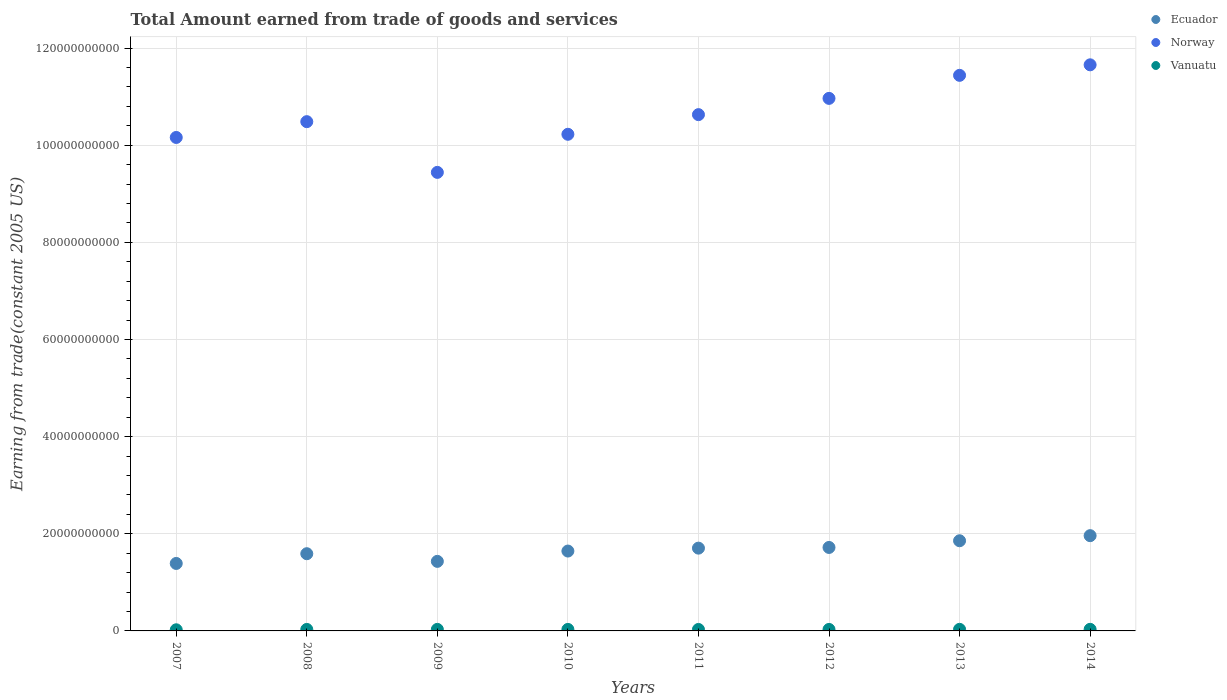How many different coloured dotlines are there?
Your answer should be very brief. 3. Is the number of dotlines equal to the number of legend labels?
Your response must be concise. Yes. What is the total amount earned by trading goods and services in Norway in 2014?
Your answer should be compact. 1.17e+11. Across all years, what is the maximum total amount earned by trading goods and services in Ecuador?
Your response must be concise. 1.96e+1. Across all years, what is the minimum total amount earned by trading goods and services in Norway?
Your response must be concise. 9.44e+1. What is the total total amount earned by trading goods and services in Vanuatu in the graph?
Keep it short and to the point. 2.42e+09. What is the difference between the total amount earned by trading goods and services in Ecuador in 2010 and that in 2014?
Give a very brief answer. -3.17e+09. What is the difference between the total amount earned by trading goods and services in Vanuatu in 2011 and the total amount earned by trading goods and services in Ecuador in 2013?
Offer a very short reply. -1.83e+1. What is the average total amount earned by trading goods and services in Norway per year?
Ensure brevity in your answer.  1.06e+11. In the year 2007, what is the difference between the total amount earned by trading goods and services in Vanuatu and total amount earned by trading goods and services in Norway?
Provide a short and direct response. -1.01e+11. What is the ratio of the total amount earned by trading goods and services in Norway in 2009 to that in 2011?
Offer a terse response. 0.89. Is the difference between the total amount earned by trading goods and services in Vanuatu in 2012 and 2014 greater than the difference between the total amount earned by trading goods and services in Norway in 2012 and 2014?
Offer a very short reply. Yes. What is the difference between the highest and the second highest total amount earned by trading goods and services in Ecuador?
Offer a very short reply. 1.05e+09. What is the difference between the highest and the lowest total amount earned by trading goods and services in Ecuador?
Give a very brief answer. 5.72e+09. In how many years, is the total amount earned by trading goods and services in Ecuador greater than the average total amount earned by trading goods and services in Ecuador taken over all years?
Keep it short and to the point. 4. Is it the case that in every year, the sum of the total amount earned by trading goods and services in Vanuatu and total amount earned by trading goods and services in Ecuador  is greater than the total amount earned by trading goods and services in Norway?
Offer a terse response. No. Are the values on the major ticks of Y-axis written in scientific E-notation?
Make the answer very short. No. Does the graph contain any zero values?
Provide a short and direct response. No. Does the graph contain grids?
Your answer should be compact. Yes. Where does the legend appear in the graph?
Your response must be concise. Top right. How are the legend labels stacked?
Give a very brief answer. Vertical. What is the title of the graph?
Give a very brief answer. Total Amount earned from trade of goods and services. What is the label or title of the X-axis?
Provide a short and direct response. Years. What is the label or title of the Y-axis?
Keep it short and to the point. Earning from trade(constant 2005 US). What is the Earning from trade(constant 2005 US) in Ecuador in 2007?
Your answer should be very brief. 1.39e+1. What is the Earning from trade(constant 2005 US) of Norway in 2007?
Your answer should be compact. 1.02e+11. What is the Earning from trade(constant 2005 US) of Vanuatu in 2007?
Provide a succinct answer. 2.33e+08. What is the Earning from trade(constant 2005 US) in Ecuador in 2008?
Provide a short and direct response. 1.59e+1. What is the Earning from trade(constant 2005 US) of Norway in 2008?
Ensure brevity in your answer.  1.05e+11. What is the Earning from trade(constant 2005 US) in Vanuatu in 2008?
Provide a succinct answer. 3.06e+08. What is the Earning from trade(constant 2005 US) of Ecuador in 2009?
Your response must be concise. 1.43e+1. What is the Earning from trade(constant 2005 US) in Norway in 2009?
Offer a terse response. 9.44e+1. What is the Earning from trade(constant 2005 US) of Vanuatu in 2009?
Ensure brevity in your answer.  3.15e+08. What is the Earning from trade(constant 2005 US) in Ecuador in 2010?
Make the answer very short. 1.64e+1. What is the Earning from trade(constant 2005 US) of Norway in 2010?
Your answer should be compact. 1.02e+11. What is the Earning from trade(constant 2005 US) of Vanuatu in 2010?
Provide a succinct answer. 3.09e+08. What is the Earning from trade(constant 2005 US) of Ecuador in 2011?
Provide a succinct answer. 1.70e+1. What is the Earning from trade(constant 2005 US) in Norway in 2011?
Ensure brevity in your answer.  1.06e+11. What is the Earning from trade(constant 2005 US) of Vanuatu in 2011?
Your answer should be compact. 3.03e+08. What is the Earning from trade(constant 2005 US) in Ecuador in 2012?
Make the answer very short. 1.72e+1. What is the Earning from trade(constant 2005 US) in Norway in 2012?
Give a very brief answer. 1.10e+11. What is the Earning from trade(constant 2005 US) of Vanuatu in 2012?
Keep it short and to the point. 3.05e+08. What is the Earning from trade(constant 2005 US) in Ecuador in 2013?
Keep it short and to the point. 1.86e+1. What is the Earning from trade(constant 2005 US) of Norway in 2013?
Give a very brief answer. 1.14e+11. What is the Earning from trade(constant 2005 US) of Vanuatu in 2013?
Provide a succinct answer. 3.25e+08. What is the Earning from trade(constant 2005 US) of Ecuador in 2014?
Provide a succinct answer. 1.96e+1. What is the Earning from trade(constant 2005 US) of Norway in 2014?
Your response must be concise. 1.17e+11. What is the Earning from trade(constant 2005 US) in Vanuatu in 2014?
Provide a short and direct response. 3.26e+08. Across all years, what is the maximum Earning from trade(constant 2005 US) of Ecuador?
Your answer should be very brief. 1.96e+1. Across all years, what is the maximum Earning from trade(constant 2005 US) in Norway?
Provide a short and direct response. 1.17e+11. Across all years, what is the maximum Earning from trade(constant 2005 US) in Vanuatu?
Give a very brief answer. 3.26e+08. Across all years, what is the minimum Earning from trade(constant 2005 US) in Ecuador?
Provide a succinct answer. 1.39e+1. Across all years, what is the minimum Earning from trade(constant 2005 US) in Norway?
Give a very brief answer. 9.44e+1. Across all years, what is the minimum Earning from trade(constant 2005 US) of Vanuatu?
Your response must be concise. 2.33e+08. What is the total Earning from trade(constant 2005 US) of Ecuador in the graph?
Provide a succinct answer. 1.33e+11. What is the total Earning from trade(constant 2005 US) of Norway in the graph?
Your response must be concise. 8.50e+11. What is the total Earning from trade(constant 2005 US) in Vanuatu in the graph?
Make the answer very short. 2.42e+09. What is the difference between the Earning from trade(constant 2005 US) in Ecuador in 2007 and that in 2008?
Provide a succinct answer. -2.01e+09. What is the difference between the Earning from trade(constant 2005 US) in Norway in 2007 and that in 2008?
Your response must be concise. -3.25e+09. What is the difference between the Earning from trade(constant 2005 US) in Vanuatu in 2007 and that in 2008?
Give a very brief answer. -7.33e+07. What is the difference between the Earning from trade(constant 2005 US) of Ecuador in 2007 and that in 2009?
Offer a terse response. -4.29e+08. What is the difference between the Earning from trade(constant 2005 US) of Norway in 2007 and that in 2009?
Your answer should be very brief. 7.19e+09. What is the difference between the Earning from trade(constant 2005 US) in Vanuatu in 2007 and that in 2009?
Provide a short and direct response. -8.23e+07. What is the difference between the Earning from trade(constant 2005 US) in Ecuador in 2007 and that in 2010?
Ensure brevity in your answer.  -2.55e+09. What is the difference between the Earning from trade(constant 2005 US) in Norway in 2007 and that in 2010?
Your answer should be compact. -6.52e+08. What is the difference between the Earning from trade(constant 2005 US) in Vanuatu in 2007 and that in 2010?
Provide a succinct answer. -7.55e+07. What is the difference between the Earning from trade(constant 2005 US) of Ecuador in 2007 and that in 2011?
Offer a terse response. -3.15e+09. What is the difference between the Earning from trade(constant 2005 US) in Norway in 2007 and that in 2011?
Ensure brevity in your answer.  -4.70e+09. What is the difference between the Earning from trade(constant 2005 US) of Vanuatu in 2007 and that in 2011?
Offer a terse response. -6.95e+07. What is the difference between the Earning from trade(constant 2005 US) in Ecuador in 2007 and that in 2012?
Ensure brevity in your answer.  -3.29e+09. What is the difference between the Earning from trade(constant 2005 US) of Norway in 2007 and that in 2012?
Ensure brevity in your answer.  -8.05e+09. What is the difference between the Earning from trade(constant 2005 US) of Vanuatu in 2007 and that in 2012?
Your answer should be very brief. -7.21e+07. What is the difference between the Earning from trade(constant 2005 US) of Ecuador in 2007 and that in 2013?
Offer a terse response. -4.67e+09. What is the difference between the Earning from trade(constant 2005 US) in Norway in 2007 and that in 2013?
Offer a very short reply. -1.28e+1. What is the difference between the Earning from trade(constant 2005 US) in Vanuatu in 2007 and that in 2013?
Provide a succinct answer. -9.18e+07. What is the difference between the Earning from trade(constant 2005 US) in Ecuador in 2007 and that in 2014?
Ensure brevity in your answer.  -5.72e+09. What is the difference between the Earning from trade(constant 2005 US) in Norway in 2007 and that in 2014?
Give a very brief answer. -1.50e+1. What is the difference between the Earning from trade(constant 2005 US) in Vanuatu in 2007 and that in 2014?
Provide a succinct answer. -9.24e+07. What is the difference between the Earning from trade(constant 2005 US) in Ecuador in 2008 and that in 2009?
Keep it short and to the point. 1.58e+09. What is the difference between the Earning from trade(constant 2005 US) of Norway in 2008 and that in 2009?
Offer a terse response. 1.04e+1. What is the difference between the Earning from trade(constant 2005 US) in Vanuatu in 2008 and that in 2009?
Your answer should be compact. -9.04e+06. What is the difference between the Earning from trade(constant 2005 US) of Ecuador in 2008 and that in 2010?
Your answer should be compact. -5.46e+08. What is the difference between the Earning from trade(constant 2005 US) of Norway in 2008 and that in 2010?
Your answer should be compact. 2.60e+09. What is the difference between the Earning from trade(constant 2005 US) of Vanuatu in 2008 and that in 2010?
Your answer should be compact. -2.21e+06. What is the difference between the Earning from trade(constant 2005 US) in Ecuador in 2008 and that in 2011?
Keep it short and to the point. -1.15e+09. What is the difference between the Earning from trade(constant 2005 US) of Norway in 2008 and that in 2011?
Offer a terse response. -1.45e+09. What is the difference between the Earning from trade(constant 2005 US) of Vanuatu in 2008 and that in 2011?
Your answer should be compact. 3.74e+06. What is the difference between the Earning from trade(constant 2005 US) of Ecuador in 2008 and that in 2012?
Keep it short and to the point. -1.29e+09. What is the difference between the Earning from trade(constant 2005 US) of Norway in 2008 and that in 2012?
Offer a very short reply. -4.79e+09. What is the difference between the Earning from trade(constant 2005 US) in Vanuatu in 2008 and that in 2012?
Ensure brevity in your answer.  1.22e+06. What is the difference between the Earning from trade(constant 2005 US) of Ecuador in 2008 and that in 2013?
Ensure brevity in your answer.  -2.67e+09. What is the difference between the Earning from trade(constant 2005 US) of Norway in 2008 and that in 2013?
Offer a very short reply. -9.54e+09. What is the difference between the Earning from trade(constant 2005 US) in Vanuatu in 2008 and that in 2013?
Offer a very short reply. -1.85e+07. What is the difference between the Earning from trade(constant 2005 US) of Ecuador in 2008 and that in 2014?
Provide a short and direct response. -3.72e+09. What is the difference between the Earning from trade(constant 2005 US) in Norway in 2008 and that in 2014?
Offer a very short reply. -1.17e+1. What is the difference between the Earning from trade(constant 2005 US) in Vanuatu in 2008 and that in 2014?
Your response must be concise. -1.91e+07. What is the difference between the Earning from trade(constant 2005 US) of Ecuador in 2009 and that in 2010?
Offer a terse response. -2.12e+09. What is the difference between the Earning from trade(constant 2005 US) of Norway in 2009 and that in 2010?
Ensure brevity in your answer.  -7.84e+09. What is the difference between the Earning from trade(constant 2005 US) of Vanuatu in 2009 and that in 2010?
Provide a short and direct response. 6.83e+06. What is the difference between the Earning from trade(constant 2005 US) of Ecuador in 2009 and that in 2011?
Keep it short and to the point. -2.72e+09. What is the difference between the Earning from trade(constant 2005 US) of Norway in 2009 and that in 2011?
Provide a succinct answer. -1.19e+1. What is the difference between the Earning from trade(constant 2005 US) in Vanuatu in 2009 and that in 2011?
Ensure brevity in your answer.  1.28e+07. What is the difference between the Earning from trade(constant 2005 US) in Ecuador in 2009 and that in 2012?
Provide a short and direct response. -2.87e+09. What is the difference between the Earning from trade(constant 2005 US) of Norway in 2009 and that in 2012?
Offer a very short reply. -1.52e+1. What is the difference between the Earning from trade(constant 2005 US) in Vanuatu in 2009 and that in 2012?
Offer a terse response. 1.03e+07. What is the difference between the Earning from trade(constant 2005 US) in Ecuador in 2009 and that in 2013?
Your answer should be compact. -4.24e+09. What is the difference between the Earning from trade(constant 2005 US) of Norway in 2009 and that in 2013?
Provide a short and direct response. -2.00e+1. What is the difference between the Earning from trade(constant 2005 US) in Vanuatu in 2009 and that in 2013?
Your answer should be compact. -9.44e+06. What is the difference between the Earning from trade(constant 2005 US) in Ecuador in 2009 and that in 2014?
Your answer should be very brief. -5.29e+09. What is the difference between the Earning from trade(constant 2005 US) of Norway in 2009 and that in 2014?
Keep it short and to the point. -2.21e+1. What is the difference between the Earning from trade(constant 2005 US) in Vanuatu in 2009 and that in 2014?
Your answer should be compact. -1.01e+07. What is the difference between the Earning from trade(constant 2005 US) of Ecuador in 2010 and that in 2011?
Provide a succinct answer. -6.00e+08. What is the difference between the Earning from trade(constant 2005 US) of Norway in 2010 and that in 2011?
Keep it short and to the point. -4.05e+09. What is the difference between the Earning from trade(constant 2005 US) of Vanuatu in 2010 and that in 2011?
Offer a terse response. 5.95e+06. What is the difference between the Earning from trade(constant 2005 US) in Ecuador in 2010 and that in 2012?
Provide a short and direct response. -7.42e+08. What is the difference between the Earning from trade(constant 2005 US) of Norway in 2010 and that in 2012?
Your answer should be very brief. -7.39e+09. What is the difference between the Earning from trade(constant 2005 US) of Vanuatu in 2010 and that in 2012?
Make the answer very short. 3.43e+06. What is the difference between the Earning from trade(constant 2005 US) in Ecuador in 2010 and that in 2013?
Offer a very short reply. -2.12e+09. What is the difference between the Earning from trade(constant 2005 US) in Norway in 2010 and that in 2013?
Offer a terse response. -1.21e+1. What is the difference between the Earning from trade(constant 2005 US) in Vanuatu in 2010 and that in 2013?
Give a very brief answer. -1.63e+07. What is the difference between the Earning from trade(constant 2005 US) in Ecuador in 2010 and that in 2014?
Provide a short and direct response. -3.17e+09. What is the difference between the Earning from trade(constant 2005 US) of Norway in 2010 and that in 2014?
Your response must be concise. -1.43e+1. What is the difference between the Earning from trade(constant 2005 US) of Vanuatu in 2010 and that in 2014?
Your response must be concise. -1.69e+07. What is the difference between the Earning from trade(constant 2005 US) in Ecuador in 2011 and that in 2012?
Your answer should be compact. -1.42e+08. What is the difference between the Earning from trade(constant 2005 US) in Norway in 2011 and that in 2012?
Provide a short and direct response. -3.35e+09. What is the difference between the Earning from trade(constant 2005 US) of Vanuatu in 2011 and that in 2012?
Give a very brief answer. -2.51e+06. What is the difference between the Earning from trade(constant 2005 US) of Ecuador in 2011 and that in 2013?
Give a very brief answer. -1.52e+09. What is the difference between the Earning from trade(constant 2005 US) of Norway in 2011 and that in 2013?
Provide a short and direct response. -8.09e+09. What is the difference between the Earning from trade(constant 2005 US) in Vanuatu in 2011 and that in 2013?
Offer a very short reply. -2.22e+07. What is the difference between the Earning from trade(constant 2005 US) of Ecuador in 2011 and that in 2014?
Offer a terse response. -2.57e+09. What is the difference between the Earning from trade(constant 2005 US) of Norway in 2011 and that in 2014?
Your response must be concise. -1.03e+1. What is the difference between the Earning from trade(constant 2005 US) of Vanuatu in 2011 and that in 2014?
Your answer should be very brief. -2.29e+07. What is the difference between the Earning from trade(constant 2005 US) in Ecuador in 2012 and that in 2013?
Provide a short and direct response. -1.38e+09. What is the difference between the Earning from trade(constant 2005 US) in Norway in 2012 and that in 2013?
Make the answer very short. -4.74e+09. What is the difference between the Earning from trade(constant 2005 US) in Vanuatu in 2012 and that in 2013?
Your answer should be very brief. -1.97e+07. What is the difference between the Earning from trade(constant 2005 US) of Ecuador in 2012 and that in 2014?
Make the answer very short. -2.43e+09. What is the difference between the Earning from trade(constant 2005 US) of Norway in 2012 and that in 2014?
Your answer should be very brief. -6.91e+09. What is the difference between the Earning from trade(constant 2005 US) of Vanuatu in 2012 and that in 2014?
Your answer should be very brief. -2.04e+07. What is the difference between the Earning from trade(constant 2005 US) in Ecuador in 2013 and that in 2014?
Provide a short and direct response. -1.05e+09. What is the difference between the Earning from trade(constant 2005 US) of Norway in 2013 and that in 2014?
Make the answer very short. -2.17e+09. What is the difference between the Earning from trade(constant 2005 US) in Vanuatu in 2013 and that in 2014?
Provide a short and direct response. -6.49e+05. What is the difference between the Earning from trade(constant 2005 US) in Ecuador in 2007 and the Earning from trade(constant 2005 US) in Norway in 2008?
Make the answer very short. -9.10e+1. What is the difference between the Earning from trade(constant 2005 US) of Ecuador in 2007 and the Earning from trade(constant 2005 US) of Vanuatu in 2008?
Keep it short and to the point. 1.36e+1. What is the difference between the Earning from trade(constant 2005 US) of Norway in 2007 and the Earning from trade(constant 2005 US) of Vanuatu in 2008?
Ensure brevity in your answer.  1.01e+11. What is the difference between the Earning from trade(constant 2005 US) in Ecuador in 2007 and the Earning from trade(constant 2005 US) in Norway in 2009?
Keep it short and to the point. -8.05e+1. What is the difference between the Earning from trade(constant 2005 US) of Ecuador in 2007 and the Earning from trade(constant 2005 US) of Vanuatu in 2009?
Offer a very short reply. 1.36e+1. What is the difference between the Earning from trade(constant 2005 US) of Norway in 2007 and the Earning from trade(constant 2005 US) of Vanuatu in 2009?
Keep it short and to the point. 1.01e+11. What is the difference between the Earning from trade(constant 2005 US) in Ecuador in 2007 and the Earning from trade(constant 2005 US) in Norway in 2010?
Provide a succinct answer. -8.84e+1. What is the difference between the Earning from trade(constant 2005 US) in Ecuador in 2007 and the Earning from trade(constant 2005 US) in Vanuatu in 2010?
Give a very brief answer. 1.36e+1. What is the difference between the Earning from trade(constant 2005 US) of Norway in 2007 and the Earning from trade(constant 2005 US) of Vanuatu in 2010?
Offer a terse response. 1.01e+11. What is the difference between the Earning from trade(constant 2005 US) in Ecuador in 2007 and the Earning from trade(constant 2005 US) in Norway in 2011?
Offer a terse response. -9.24e+1. What is the difference between the Earning from trade(constant 2005 US) of Ecuador in 2007 and the Earning from trade(constant 2005 US) of Vanuatu in 2011?
Give a very brief answer. 1.36e+1. What is the difference between the Earning from trade(constant 2005 US) in Norway in 2007 and the Earning from trade(constant 2005 US) in Vanuatu in 2011?
Your response must be concise. 1.01e+11. What is the difference between the Earning from trade(constant 2005 US) in Ecuador in 2007 and the Earning from trade(constant 2005 US) in Norway in 2012?
Your answer should be very brief. -9.58e+1. What is the difference between the Earning from trade(constant 2005 US) of Ecuador in 2007 and the Earning from trade(constant 2005 US) of Vanuatu in 2012?
Your answer should be very brief. 1.36e+1. What is the difference between the Earning from trade(constant 2005 US) of Norway in 2007 and the Earning from trade(constant 2005 US) of Vanuatu in 2012?
Make the answer very short. 1.01e+11. What is the difference between the Earning from trade(constant 2005 US) in Ecuador in 2007 and the Earning from trade(constant 2005 US) in Norway in 2013?
Provide a succinct answer. -1.01e+11. What is the difference between the Earning from trade(constant 2005 US) in Ecuador in 2007 and the Earning from trade(constant 2005 US) in Vanuatu in 2013?
Keep it short and to the point. 1.36e+1. What is the difference between the Earning from trade(constant 2005 US) of Norway in 2007 and the Earning from trade(constant 2005 US) of Vanuatu in 2013?
Your answer should be compact. 1.01e+11. What is the difference between the Earning from trade(constant 2005 US) of Ecuador in 2007 and the Earning from trade(constant 2005 US) of Norway in 2014?
Ensure brevity in your answer.  -1.03e+11. What is the difference between the Earning from trade(constant 2005 US) of Ecuador in 2007 and the Earning from trade(constant 2005 US) of Vanuatu in 2014?
Keep it short and to the point. 1.36e+1. What is the difference between the Earning from trade(constant 2005 US) of Norway in 2007 and the Earning from trade(constant 2005 US) of Vanuatu in 2014?
Your response must be concise. 1.01e+11. What is the difference between the Earning from trade(constant 2005 US) in Ecuador in 2008 and the Earning from trade(constant 2005 US) in Norway in 2009?
Offer a terse response. -7.85e+1. What is the difference between the Earning from trade(constant 2005 US) in Ecuador in 2008 and the Earning from trade(constant 2005 US) in Vanuatu in 2009?
Give a very brief answer. 1.56e+1. What is the difference between the Earning from trade(constant 2005 US) in Norway in 2008 and the Earning from trade(constant 2005 US) in Vanuatu in 2009?
Your answer should be compact. 1.05e+11. What is the difference between the Earning from trade(constant 2005 US) in Ecuador in 2008 and the Earning from trade(constant 2005 US) in Norway in 2010?
Your answer should be very brief. -8.64e+1. What is the difference between the Earning from trade(constant 2005 US) of Ecuador in 2008 and the Earning from trade(constant 2005 US) of Vanuatu in 2010?
Make the answer very short. 1.56e+1. What is the difference between the Earning from trade(constant 2005 US) in Norway in 2008 and the Earning from trade(constant 2005 US) in Vanuatu in 2010?
Your answer should be very brief. 1.05e+11. What is the difference between the Earning from trade(constant 2005 US) of Ecuador in 2008 and the Earning from trade(constant 2005 US) of Norway in 2011?
Keep it short and to the point. -9.04e+1. What is the difference between the Earning from trade(constant 2005 US) in Ecuador in 2008 and the Earning from trade(constant 2005 US) in Vanuatu in 2011?
Your answer should be very brief. 1.56e+1. What is the difference between the Earning from trade(constant 2005 US) of Norway in 2008 and the Earning from trade(constant 2005 US) of Vanuatu in 2011?
Your answer should be very brief. 1.05e+11. What is the difference between the Earning from trade(constant 2005 US) in Ecuador in 2008 and the Earning from trade(constant 2005 US) in Norway in 2012?
Make the answer very short. -9.38e+1. What is the difference between the Earning from trade(constant 2005 US) in Ecuador in 2008 and the Earning from trade(constant 2005 US) in Vanuatu in 2012?
Offer a very short reply. 1.56e+1. What is the difference between the Earning from trade(constant 2005 US) of Norway in 2008 and the Earning from trade(constant 2005 US) of Vanuatu in 2012?
Provide a short and direct response. 1.05e+11. What is the difference between the Earning from trade(constant 2005 US) of Ecuador in 2008 and the Earning from trade(constant 2005 US) of Norway in 2013?
Make the answer very short. -9.85e+1. What is the difference between the Earning from trade(constant 2005 US) in Ecuador in 2008 and the Earning from trade(constant 2005 US) in Vanuatu in 2013?
Your answer should be compact. 1.56e+1. What is the difference between the Earning from trade(constant 2005 US) of Norway in 2008 and the Earning from trade(constant 2005 US) of Vanuatu in 2013?
Your answer should be compact. 1.05e+11. What is the difference between the Earning from trade(constant 2005 US) of Ecuador in 2008 and the Earning from trade(constant 2005 US) of Norway in 2014?
Your answer should be compact. -1.01e+11. What is the difference between the Earning from trade(constant 2005 US) of Ecuador in 2008 and the Earning from trade(constant 2005 US) of Vanuatu in 2014?
Keep it short and to the point. 1.56e+1. What is the difference between the Earning from trade(constant 2005 US) of Norway in 2008 and the Earning from trade(constant 2005 US) of Vanuatu in 2014?
Provide a short and direct response. 1.05e+11. What is the difference between the Earning from trade(constant 2005 US) in Ecuador in 2009 and the Earning from trade(constant 2005 US) in Norway in 2010?
Ensure brevity in your answer.  -8.79e+1. What is the difference between the Earning from trade(constant 2005 US) in Ecuador in 2009 and the Earning from trade(constant 2005 US) in Vanuatu in 2010?
Offer a very short reply. 1.40e+1. What is the difference between the Earning from trade(constant 2005 US) in Norway in 2009 and the Earning from trade(constant 2005 US) in Vanuatu in 2010?
Your response must be concise. 9.41e+1. What is the difference between the Earning from trade(constant 2005 US) in Ecuador in 2009 and the Earning from trade(constant 2005 US) in Norway in 2011?
Your answer should be very brief. -9.20e+1. What is the difference between the Earning from trade(constant 2005 US) of Ecuador in 2009 and the Earning from trade(constant 2005 US) of Vanuatu in 2011?
Give a very brief answer. 1.40e+1. What is the difference between the Earning from trade(constant 2005 US) in Norway in 2009 and the Earning from trade(constant 2005 US) in Vanuatu in 2011?
Keep it short and to the point. 9.41e+1. What is the difference between the Earning from trade(constant 2005 US) of Ecuador in 2009 and the Earning from trade(constant 2005 US) of Norway in 2012?
Offer a very short reply. -9.53e+1. What is the difference between the Earning from trade(constant 2005 US) of Ecuador in 2009 and the Earning from trade(constant 2005 US) of Vanuatu in 2012?
Make the answer very short. 1.40e+1. What is the difference between the Earning from trade(constant 2005 US) in Norway in 2009 and the Earning from trade(constant 2005 US) in Vanuatu in 2012?
Your response must be concise. 9.41e+1. What is the difference between the Earning from trade(constant 2005 US) in Ecuador in 2009 and the Earning from trade(constant 2005 US) in Norway in 2013?
Give a very brief answer. -1.00e+11. What is the difference between the Earning from trade(constant 2005 US) in Ecuador in 2009 and the Earning from trade(constant 2005 US) in Vanuatu in 2013?
Make the answer very short. 1.40e+1. What is the difference between the Earning from trade(constant 2005 US) of Norway in 2009 and the Earning from trade(constant 2005 US) of Vanuatu in 2013?
Give a very brief answer. 9.41e+1. What is the difference between the Earning from trade(constant 2005 US) in Ecuador in 2009 and the Earning from trade(constant 2005 US) in Norway in 2014?
Provide a succinct answer. -1.02e+11. What is the difference between the Earning from trade(constant 2005 US) of Ecuador in 2009 and the Earning from trade(constant 2005 US) of Vanuatu in 2014?
Your answer should be compact. 1.40e+1. What is the difference between the Earning from trade(constant 2005 US) of Norway in 2009 and the Earning from trade(constant 2005 US) of Vanuatu in 2014?
Provide a short and direct response. 9.41e+1. What is the difference between the Earning from trade(constant 2005 US) in Ecuador in 2010 and the Earning from trade(constant 2005 US) in Norway in 2011?
Provide a succinct answer. -8.99e+1. What is the difference between the Earning from trade(constant 2005 US) of Ecuador in 2010 and the Earning from trade(constant 2005 US) of Vanuatu in 2011?
Provide a succinct answer. 1.61e+1. What is the difference between the Earning from trade(constant 2005 US) in Norway in 2010 and the Earning from trade(constant 2005 US) in Vanuatu in 2011?
Keep it short and to the point. 1.02e+11. What is the difference between the Earning from trade(constant 2005 US) in Ecuador in 2010 and the Earning from trade(constant 2005 US) in Norway in 2012?
Ensure brevity in your answer.  -9.32e+1. What is the difference between the Earning from trade(constant 2005 US) of Ecuador in 2010 and the Earning from trade(constant 2005 US) of Vanuatu in 2012?
Provide a succinct answer. 1.61e+1. What is the difference between the Earning from trade(constant 2005 US) in Norway in 2010 and the Earning from trade(constant 2005 US) in Vanuatu in 2012?
Your answer should be very brief. 1.02e+11. What is the difference between the Earning from trade(constant 2005 US) in Ecuador in 2010 and the Earning from trade(constant 2005 US) in Norway in 2013?
Your answer should be compact. -9.80e+1. What is the difference between the Earning from trade(constant 2005 US) in Ecuador in 2010 and the Earning from trade(constant 2005 US) in Vanuatu in 2013?
Keep it short and to the point. 1.61e+1. What is the difference between the Earning from trade(constant 2005 US) in Norway in 2010 and the Earning from trade(constant 2005 US) in Vanuatu in 2013?
Your answer should be very brief. 1.02e+11. What is the difference between the Earning from trade(constant 2005 US) of Ecuador in 2010 and the Earning from trade(constant 2005 US) of Norway in 2014?
Give a very brief answer. -1.00e+11. What is the difference between the Earning from trade(constant 2005 US) of Ecuador in 2010 and the Earning from trade(constant 2005 US) of Vanuatu in 2014?
Offer a very short reply. 1.61e+1. What is the difference between the Earning from trade(constant 2005 US) of Norway in 2010 and the Earning from trade(constant 2005 US) of Vanuatu in 2014?
Offer a very short reply. 1.02e+11. What is the difference between the Earning from trade(constant 2005 US) in Ecuador in 2011 and the Earning from trade(constant 2005 US) in Norway in 2012?
Your answer should be very brief. -9.26e+1. What is the difference between the Earning from trade(constant 2005 US) of Ecuador in 2011 and the Earning from trade(constant 2005 US) of Vanuatu in 2012?
Offer a terse response. 1.67e+1. What is the difference between the Earning from trade(constant 2005 US) in Norway in 2011 and the Earning from trade(constant 2005 US) in Vanuatu in 2012?
Your answer should be compact. 1.06e+11. What is the difference between the Earning from trade(constant 2005 US) in Ecuador in 2011 and the Earning from trade(constant 2005 US) in Norway in 2013?
Provide a succinct answer. -9.74e+1. What is the difference between the Earning from trade(constant 2005 US) in Ecuador in 2011 and the Earning from trade(constant 2005 US) in Vanuatu in 2013?
Your answer should be compact. 1.67e+1. What is the difference between the Earning from trade(constant 2005 US) in Norway in 2011 and the Earning from trade(constant 2005 US) in Vanuatu in 2013?
Your answer should be very brief. 1.06e+11. What is the difference between the Earning from trade(constant 2005 US) in Ecuador in 2011 and the Earning from trade(constant 2005 US) in Norway in 2014?
Your response must be concise. -9.95e+1. What is the difference between the Earning from trade(constant 2005 US) of Ecuador in 2011 and the Earning from trade(constant 2005 US) of Vanuatu in 2014?
Give a very brief answer. 1.67e+1. What is the difference between the Earning from trade(constant 2005 US) of Norway in 2011 and the Earning from trade(constant 2005 US) of Vanuatu in 2014?
Offer a terse response. 1.06e+11. What is the difference between the Earning from trade(constant 2005 US) of Ecuador in 2012 and the Earning from trade(constant 2005 US) of Norway in 2013?
Ensure brevity in your answer.  -9.72e+1. What is the difference between the Earning from trade(constant 2005 US) of Ecuador in 2012 and the Earning from trade(constant 2005 US) of Vanuatu in 2013?
Your response must be concise. 1.69e+1. What is the difference between the Earning from trade(constant 2005 US) of Norway in 2012 and the Earning from trade(constant 2005 US) of Vanuatu in 2013?
Make the answer very short. 1.09e+11. What is the difference between the Earning from trade(constant 2005 US) in Ecuador in 2012 and the Earning from trade(constant 2005 US) in Norway in 2014?
Give a very brief answer. -9.94e+1. What is the difference between the Earning from trade(constant 2005 US) of Ecuador in 2012 and the Earning from trade(constant 2005 US) of Vanuatu in 2014?
Ensure brevity in your answer.  1.69e+1. What is the difference between the Earning from trade(constant 2005 US) in Norway in 2012 and the Earning from trade(constant 2005 US) in Vanuatu in 2014?
Provide a short and direct response. 1.09e+11. What is the difference between the Earning from trade(constant 2005 US) in Ecuador in 2013 and the Earning from trade(constant 2005 US) in Norway in 2014?
Give a very brief answer. -9.80e+1. What is the difference between the Earning from trade(constant 2005 US) in Ecuador in 2013 and the Earning from trade(constant 2005 US) in Vanuatu in 2014?
Provide a succinct answer. 1.82e+1. What is the difference between the Earning from trade(constant 2005 US) of Norway in 2013 and the Earning from trade(constant 2005 US) of Vanuatu in 2014?
Provide a short and direct response. 1.14e+11. What is the average Earning from trade(constant 2005 US) of Ecuador per year?
Make the answer very short. 1.66e+1. What is the average Earning from trade(constant 2005 US) of Norway per year?
Give a very brief answer. 1.06e+11. What is the average Earning from trade(constant 2005 US) of Vanuatu per year?
Offer a terse response. 3.03e+08. In the year 2007, what is the difference between the Earning from trade(constant 2005 US) in Ecuador and Earning from trade(constant 2005 US) in Norway?
Ensure brevity in your answer.  -8.77e+1. In the year 2007, what is the difference between the Earning from trade(constant 2005 US) of Ecuador and Earning from trade(constant 2005 US) of Vanuatu?
Offer a very short reply. 1.37e+1. In the year 2007, what is the difference between the Earning from trade(constant 2005 US) of Norway and Earning from trade(constant 2005 US) of Vanuatu?
Give a very brief answer. 1.01e+11. In the year 2008, what is the difference between the Earning from trade(constant 2005 US) of Ecuador and Earning from trade(constant 2005 US) of Norway?
Provide a short and direct response. -8.90e+1. In the year 2008, what is the difference between the Earning from trade(constant 2005 US) in Ecuador and Earning from trade(constant 2005 US) in Vanuatu?
Ensure brevity in your answer.  1.56e+1. In the year 2008, what is the difference between the Earning from trade(constant 2005 US) of Norway and Earning from trade(constant 2005 US) of Vanuatu?
Offer a terse response. 1.05e+11. In the year 2009, what is the difference between the Earning from trade(constant 2005 US) in Ecuador and Earning from trade(constant 2005 US) in Norway?
Provide a succinct answer. -8.01e+1. In the year 2009, what is the difference between the Earning from trade(constant 2005 US) of Ecuador and Earning from trade(constant 2005 US) of Vanuatu?
Provide a succinct answer. 1.40e+1. In the year 2009, what is the difference between the Earning from trade(constant 2005 US) of Norway and Earning from trade(constant 2005 US) of Vanuatu?
Provide a short and direct response. 9.41e+1. In the year 2010, what is the difference between the Earning from trade(constant 2005 US) in Ecuador and Earning from trade(constant 2005 US) in Norway?
Provide a short and direct response. -8.58e+1. In the year 2010, what is the difference between the Earning from trade(constant 2005 US) of Ecuador and Earning from trade(constant 2005 US) of Vanuatu?
Offer a very short reply. 1.61e+1. In the year 2010, what is the difference between the Earning from trade(constant 2005 US) of Norway and Earning from trade(constant 2005 US) of Vanuatu?
Ensure brevity in your answer.  1.02e+11. In the year 2011, what is the difference between the Earning from trade(constant 2005 US) in Ecuador and Earning from trade(constant 2005 US) in Norway?
Ensure brevity in your answer.  -8.93e+1. In the year 2011, what is the difference between the Earning from trade(constant 2005 US) in Ecuador and Earning from trade(constant 2005 US) in Vanuatu?
Your answer should be compact. 1.67e+1. In the year 2011, what is the difference between the Earning from trade(constant 2005 US) of Norway and Earning from trade(constant 2005 US) of Vanuatu?
Offer a terse response. 1.06e+11. In the year 2012, what is the difference between the Earning from trade(constant 2005 US) in Ecuador and Earning from trade(constant 2005 US) in Norway?
Offer a very short reply. -9.25e+1. In the year 2012, what is the difference between the Earning from trade(constant 2005 US) in Ecuador and Earning from trade(constant 2005 US) in Vanuatu?
Give a very brief answer. 1.69e+1. In the year 2012, what is the difference between the Earning from trade(constant 2005 US) in Norway and Earning from trade(constant 2005 US) in Vanuatu?
Your response must be concise. 1.09e+11. In the year 2013, what is the difference between the Earning from trade(constant 2005 US) in Ecuador and Earning from trade(constant 2005 US) in Norway?
Your answer should be compact. -9.58e+1. In the year 2013, what is the difference between the Earning from trade(constant 2005 US) of Ecuador and Earning from trade(constant 2005 US) of Vanuatu?
Ensure brevity in your answer.  1.82e+1. In the year 2013, what is the difference between the Earning from trade(constant 2005 US) of Norway and Earning from trade(constant 2005 US) of Vanuatu?
Keep it short and to the point. 1.14e+11. In the year 2014, what is the difference between the Earning from trade(constant 2005 US) of Ecuador and Earning from trade(constant 2005 US) of Norway?
Your answer should be very brief. -9.69e+1. In the year 2014, what is the difference between the Earning from trade(constant 2005 US) in Ecuador and Earning from trade(constant 2005 US) in Vanuatu?
Keep it short and to the point. 1.93e+1. In the year 2014, what is the difference between the Earning from trade(constant 2005 US) of Norway and Earning from trade(constant 2005 US) of Vanuatu?
Provide a short and direct response. 1.16e+11. What is the ratio of the Earning from trade(constant 2005 US) in Ecuador in 2007 to that in 2008?
Offer a very short reply. 0.87. What is the ratio of the Earning from trade(constant 2005 US) in Norway in 2007 to that in 2008?
Provide a short and direct response. 0.97. What is the ratio of the Earning from trade(constant 2005 US) in Vanuatu in 2007 to that in 2008?
Your response must be concise. 0.76. What is the ratio of the Earning from trade(constant 2005 US) in Ecuador in 2007 to that in 2009?
Your response must be concise. 0.97. What is the ratio of the Earning from trade(constant 2005 US) of Norway in 2007 to that in 2009?
Your answer should be very brief. 1.08. What is the ratio of the Earning from trade(constant 2005 US) in Vanuatu in 2007 to that in 2009?
Your response must be concise. 0.74. What is the ratio of the Earning from trade(constant 2005 US) in Ecuador in 2007 to that in 2010?
Provide a succinct answer. 0.84. What is the ratio of the Earning from trade(constant 2005 US) of Vanuatu in 2007 to that in 2010?
Give a very brief answer. 0.76. What is the ratio of the Earning from trade(constant 2005 US) of Ecuador in 2007 to that in 2011?
Provide a succinct answer. 0.82. What is the ratio of the Earning from trade(constant 2005 US) of Norway in 2007 to that in 2011?
Provide a succinct answer. 0.96. What is the ratio of the Earning from trade(constant 2005 US) of Vanuatu in 2007 to that in 2011?
Offer a very short reply. 0.77. What is the ratio of the Earning from trade(constant 2005 US) of Ecuador in 2007 to that in 2012?
Give a very brief answer. 0.81. What is the ratio of the Earning from trade(constant 2005 US) of Norway in 2007 to that in 2012?
Your answer should be very brief. 0.93. What is the ratio of the Earning from trade(constant 2005 US) in Vanuatu in 2007 to that in 2012?
Offer a very short reply. 0.76. What is the ratio of the Earning from trade(constant 2005 US) of Ecuador in 2007 to that in 2013?
Keep it short and to the point. 0.75. What is the ratio of the Earning from trade(constant 2005 US) in Norway in 2007 to that in 2013?
Make the answer very short. 0.89. What is the ratio of the Earning from trade(constant 2005 US) of Vanuatu in 2007 to that in 2013?
Ensure brevity in your answer.  0.72. What is the ratio of the Earning from trade(constant 2005 US) in Ecuador in 2007 to that in 2014?
Provide a succinct answer. 0.71. What is the ratio of the Earning from trade(constant 2005 US) of Norway in 2007 to that in 2014?
Give a very brief answer. 0.87. What is the ratio of the Earning from trade(constant 2005 US) in Vanuatu in 2007 to that in 2014?
Your answer should be compact. 0.72. What is the ratio of the Earning from trade(constant 2005 US) in Ecuador in 2008 to that in 2009?
Give a very brief answer. 1.11. What is the ratio of the Earning from trade(constant 2005 US) in Norway in 2008 to that in 2009?
Give a very brief answer. 1.11. What is the ratio of the Earning from trade(constant 2005 US) of Vanuatu in 2008 to that in 2009?
Your response must be concise. 0.97. What is the ratio of the Earning from trade(constant 2005 US) in Ecuador in 2008 to that in 2010?
Keep it short and to the point. 0.97. What is the ratio of the Earning from trade(constant 2005 US) of Norway in 2008 to that in 2010?
Keep it short and to the point. 1.03. What is the ratio of the Earning from trade(constant 2005 US) of Ecuador in 2008 to that in 2011?
Offer a very short reply. 0.93. What is the ratio of the Earning from trade(constant 2005 US) of Norway in 2008 to that in 2011?
Offer a terse response. 0.99. What is the ratio of the Earning from trade(constant 2005 US) in Vanuatu in 2008 to that in 2011?
Give a very brief answer. 1.01. What is the ratio of the Earning from trade(constant 2005 US) in Ecuador in 2008 to that in 2012?
Ensure brevity in your answer.  0.93. What is the ratio of the Earning from trade(constant 2005 US) in Norway in 2008 to that in 2012?
Offer a very short reply. 0.96. What is the ratio of the Earning from trade(constant 2005 US) in Ecuador in 2008 to that in 2013?
Offer a terse response. 0.86. What is the ratio of the Earning from trade(constant 2005 US) in Norway in 2008 to that in 2013?
Ensure brevity in your answer.  0.92. What is the ratio of the Earning from trade(constant 2005 US) of Vanuatu in 2008 to that in 2013?
Offer a terse response. 0.94. What is the ratio of the Earning from trade(constant 2005 US) in Ecuador in 2008 to that in 2014?
Offer a terse response. 0.81. What is the ratio of the Earning from trade(constant 2005 US) of Norway in 2008 to that in 2014?
Your answer should be compact. 0.9. What is the ratio of the Earning from trade(constant 2005 US) in Ecuador in 2009 to that in 2010?
Keep it short and to the point. 0.87. What is the ratio of the Earning from trade(constant 2005 US) in Norway in 2009 to that in 2010?
Provide a succinct answer. 0.92. What is the ratio of the Earning from trade(constant 2005 US) in Vanuatu in 2009 to that in 2010?
Your answer should be compact. 1.02. What is the ratio of the Earning from trade(constant 2005 US) in Ecuador in 2009 to that in 2011?
Your response must be concise. 0.84. What is the ratio of the Earning from trade(constant 2005 US) of Norway in 2009 to that in 2011?
Your answer should be very brief. 0.89. What is the ratio of the Earning from trade(constant 2005 US) of Vanuatu in 2009 to that in 2011?
Make the answer very short. 1.04. What is the ratio of the Earning from trade(constant 2005 US) in Ecuador in 2009 to that in 2012?
Your answer should be compact. 0.83. What is the ratio of the Earning from trade(constant 2005 US) of Norway in 2009 to that in 2012?
Your answer should be very brief. 0.86. What is the ratio of the Earning from trade(constant 2005 US) of Vanuatu in 2009 to that in 2012?
Your response must be concise. 1.03. What is the ratio of the Earning from trade(constant 2005 US) in Ecuador in 2009 to that in 2013?
Your answer should be very brief. 0.77. What is the ratio of the Earning from trade(constant 2005 US) of Norway in 2009 to that in 2013?
Provide a succinct answer. 0.83. What is the ratio of the Earning from trade(constant 2005 US) of Vanuatu in 2009 to that in 2013?
Provide a short and direct response. 0.97. What is the ratio of the Earning from trade(constant 2005 US) of Ecuador in 2009 to that in 2014?
Your answer should be very brief. 0.73. What is the ratio of the Earning from trade(constant 2005 US) of Norway in 2009 to that in 2014?
Offer a very short reply. 0.81. What is the ratio of the Earning from trade(constant 2005 US) of Vanuatu in 2009 to that in 2014?
Make the answer very short. 0.97. What is the ratio of the Earning from trade(constant 2005 US) in Ecuador in 2010 to that in 2011?
Give a very brief answer. 0.96. What is the ratio of the Earning from trade(constant 2005 US) of Norway in 2010 to that in 2011?
Offer a terse response. 0.96. What is the ratio of the Earning from trade(constant 2005 US) in Vanuatu in 2010 to that in 2011?
Provide a succinct answer. 1.02. What is the ratio of the Earning from trade(constant 2005 US) in Ecuador in 2010 to that in 2012?
Your response must be concise. 0.96. What is the ratio of the Earning from trade(constant 2005 US) in Norway in 2010 to that in 2012?
Your response must be concise. 0.93. What is the ratio of the Earning from trade(constant 2005 US) of Vanuatu in 2010 to that in 2012?
Offer a very short reply. 1.01. What is the ratio of the Earning from trade(constant 2005 US) in Ecuador in 2010 to that in 2013?
Ensure brevity in your answer.  0.89. What is the ratio of the Earning from trade(constant 2005 US) of Norway in 2010 to that in 2013?
Provide a short and direct response. 0.89. What is the ratio of the Earning from trade(constant 2005 US) in Vanuatu in 2010 to that in 2013?
Provide a succinct answer. 0.95. What is the ratio of the Earning from trade(constant 2005 US) of Ecuador in 2010 to that in 2014?
Keep it short and to the point. 0.84. What is the ratio of the Earning from trade(constant 2005 US) in Norway in 2010 to that in 2014?
Offer a terse response. 0.88. What is the ratio of the Earning from trade(constant 2005 US) in Vanuatu in 2010 to that in 2014?
Provide a succinct answer. 0.95. What is the ratio of the Earning from trade(constant 2005 US) of Ecuador in 2011 to that in 2012?
Offer a terse response. 0.99. What is the ratio of the Earning from trade(constant 2005 US) in Norway in 2011 to that in 2012?
Offer a very short reply. 0.97. What is the ratio of the Earning from trade(constant 2005 US) of Vanuatu in 2011 to that in 2012?
Offer a terse response. 0.99. What is the ratio of the Earning from trade(constant 2005 US) of Ecuador in 2011 to that in 2013?
Your answer should be very brief. 0.92. What is the ratio of the Earning from trade(constant 2005 US) of Norway in 2011 to that in 2013?
Give a very brief answer. 0.93. What is the ratio of the Earning from trade(constant 2005 US) of Vanuatu in 2011 to that in 2013?
Give a very brief answer. 0.93. What is the ratio of the Earning from trade(constant 2005 US) of Ecuador in 2011 to that in 2014?
Make the answer very short. 0.87. What is the ratio of the Earning from trade(constant 2005 US) in Norway in 2011 to that in 2014?
Ensure brevity in your answer.  0.91. What is the ratio of the Earning from trade(constant 2005 US) in Vanuatu in 2011 to that in 2014?
Offer a terse response. 0.93. What is the ratio of the Earning from trade(constant 2005 US) of Ecuador in 2012 to that in 2013?
Keep it short and to the point. 0.93. What is the ratio of the Earning from trade(constant 2005 US) in Norway in 2012 to that in 2013?
Make the answer very short. 0.96. What is the ratio of the Earning from trade(constant 2005 US) of Vanuatu in 2012 to that in 2013?
Make the answer very short. 0.94. What is the ratio of the Earning from trade(constant 2005 US) in Ecuador in 2012 to that in 2014?
Offer a terse response. 0.88. What is the ratio of the Earning from trade(constant 2005 US) in Norway in 2012 to that in 2014?
Ensure brevity in your answer.  0.94. What is the ratio of the Earning from trade(constant 2005 US) of Ecuador in 2013 to that in 2014?
Give a very brief answer. 0.95. What is the ratio of the Earning from trade(constant 2005 US) in Norway in 2013 to that in 2014?
Ensure brevity in your answer.  0.98. What is the ratio of the Earning from trade(constant 2005 US) of Vanuatu in 2013 to that in 2014?
Your answer should be compact. 1. What is the difference between the highest and the second highest Earning from trade(constant 2005 US) in Ecuador?
Offer a very short reply. 1.05e+09. What is the difference between the highest and the second highest Earning from trade(constant 2005 US) in Norway?
Your response must be concise. 2.17e+09. What is the difference between the highest and the second highest Earning from trade(constant 2005 US) of Vanuatu?
Give a very brief answer. 6.49e+05. What is the difference between the highest and the lowest Earning from trade(constant 2005 US) of Ecuador?
Your response must be concise. 5.72e+09. What is the difference between the highest and the lowest Earning from trade(constant 2005 US) of Norway?
Keep it short and to the point. 2.21e+1. What is the difference between the highest and the lowest Earning from trade(constant 2005 US) in Vanuatu?
Offer a terse response. 9.24e+07. 